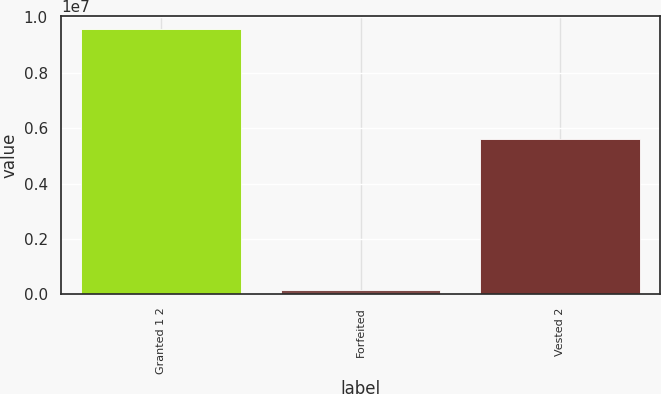<chart> <loc_0><loc_0><loc_500><loc_500><bar_chart><fcel>Granted 1 2<fcel>Forfeited<fcel>Vested 2<nl><fcel>9.56778e+06<fcel>158958<fcel>5.60211e+06<nl></chart> 